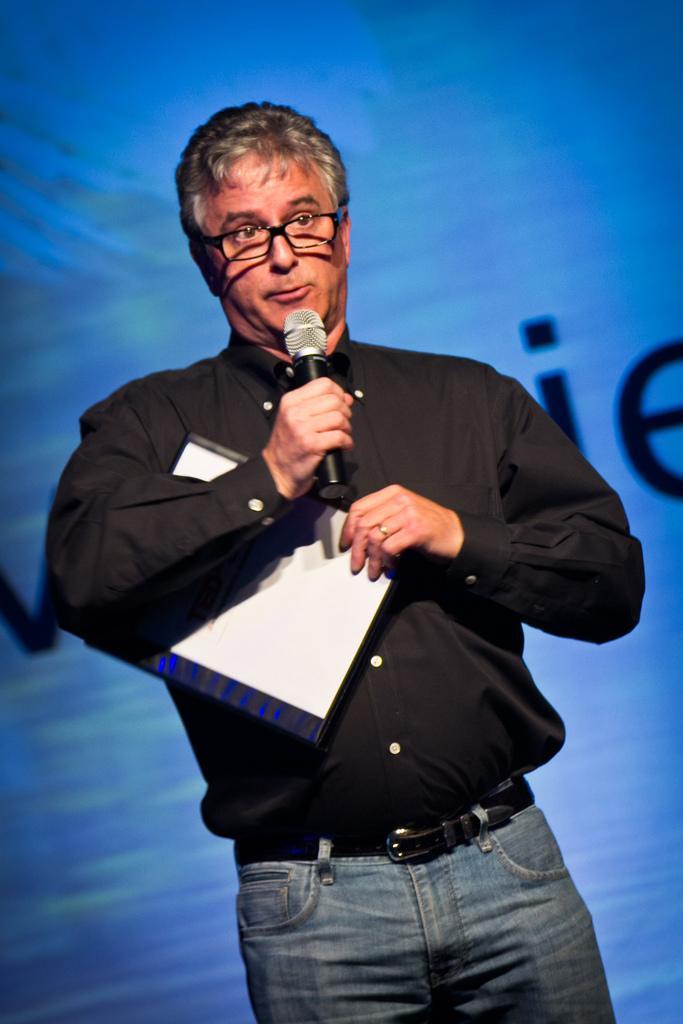Could you give a brief overview of what you see in this image? In this picture we can see a man who is holding a mike with his hand. He has spectacles and he is in black color shirt. 